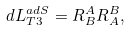Convert formula to latex. <formula><loc_0><loc_0><loc_500><loc_500>d L _ { T 3 } ^ { a d S } = R _ { B } ^ { A } R _ { A } ^ { B } ,</formula> 